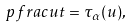<formula> <loc_0><loc_0><loc_500><loc_500>\ p f r a c { u } { t } = \tau _ { \alpha } ( u ) ,</formula> 